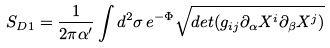Convert formula to latex. <formula><loc_0><loc_0><loc_500><loc_500>S _ { D 1 } = \frac { 1 } { 2 \pi \alpha ^ { \prime } } \int d ^ { 2 } \sigma \, e ^ { - \Phi } \sqrt { d e t ( g _ { i j } \partial _ { \alpha } X ^ { i } \partial _ { \beta } X ^ { j } ) }</formula> 